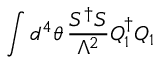<formula> <loc_0><loc_0><loc_500><loc_500>\int d ^ { 4 } \theta \, \frac { S ^ { \dag } S } { \Lambda ^ { 2 } } Q _ { 1 } ^ { \dag } Q _ { 1 }</formula> 